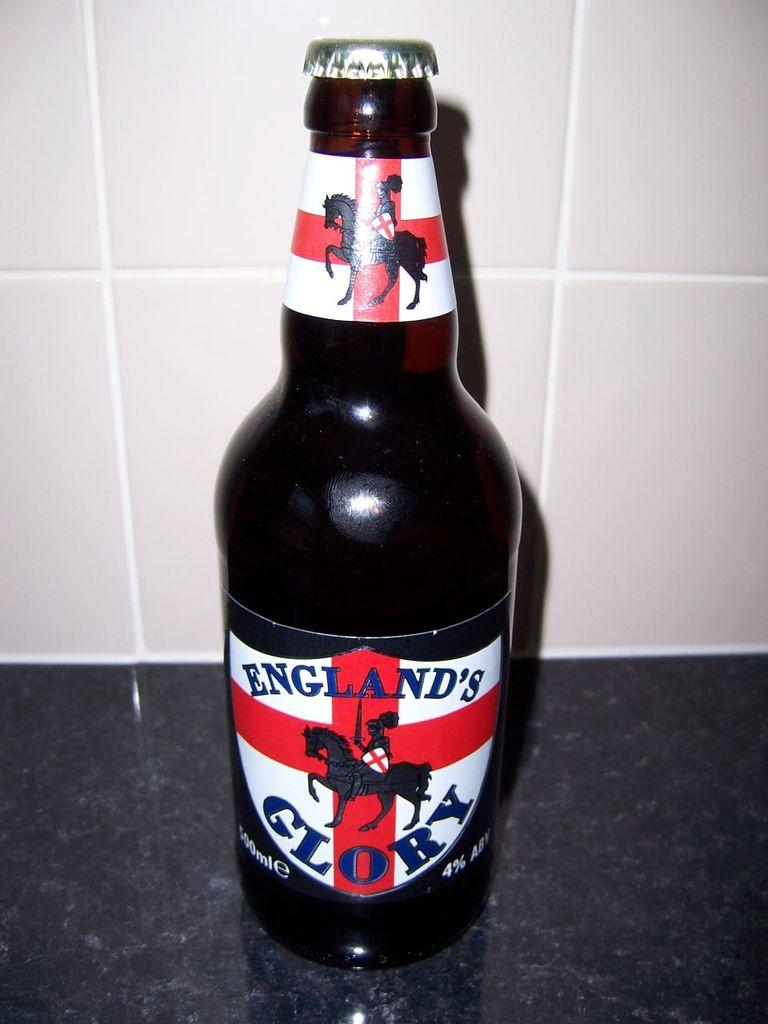<image>
Give a short and clear explanation of the subsequent image. a close up of England's Glory on a marble counter 